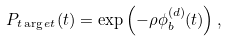Convert formula to latex. <formula><loc_0><loc_0><loc_500><loc_500>P _ { t \arg e t } ( t ) = \exp \left ( - \rho \phi _ { b } ^ { ( d ) } ( t ) \right ) ,</formula> 